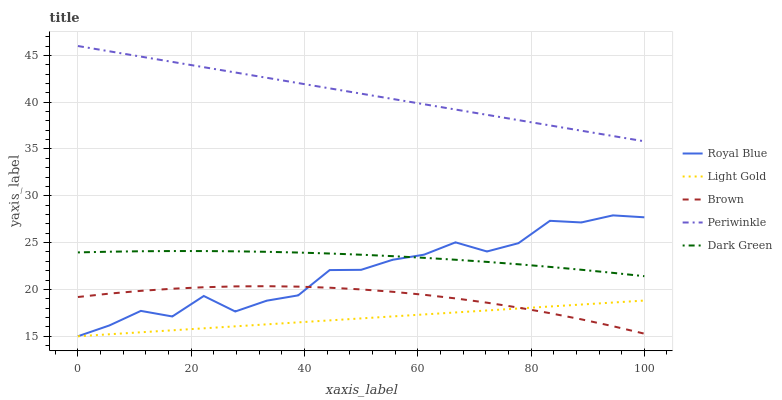Does Light Gold have the minimum area under the curve?
Answer yes or no. Yes. Does Periwinkle have the maximum area under the curve?
Answer yes or no. Yes. Does Dark Green have the minimum area under the curve?
Answer yes or no. No. Does Dark Green have the maximum area under the curve?
Answer yes or no. No. Is Light Gold the smoothest?
Answer yes or no. Yes. Is Royal Blue the roughest?
Answer yes or no. Yes. Is Periwinkle the smoothest?
Answer yes or no. No. Is Periwinkle the roughest?
Answer yes or no. No. Does Royal Blue have the lowest value?
Answer yes or no. Yes. Does Dark Green have the lowest value?
Answer yes or no. No. Does Periwinkle have the highest value?
Answer yes or no. Yes. Does Dark Green have the highest value?
Answer yes or no. No. Is Royal Blue less than Periwinkle?
Answer yes or no. Yes. Is Periwinkle greater than Dark Green?
Answer yes or no. Yes. Does Royal Blue intersect Brown?
Answer yes or no. Yes. Is Royal Blue less than Brown?
Answer yes or no. No. Is Royal Blue greater than Brown?
Answer yes or no. No. Does Royal Blue intersect Periwinkle?
Answer yes or no. No. 